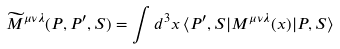Convert formula to latex. <formula><loc_0><loc_0><loc_500><loc_500>\widetilde { M } ^ { \mu \nu \lambda } ( P , P ^ { \prime } , S ) = \int d ^ { 3 } x \, \langle P ^ { \prime } , S | M ^ { \mu \nu \lambda } ( x ) | P , S \rangle</formula> 